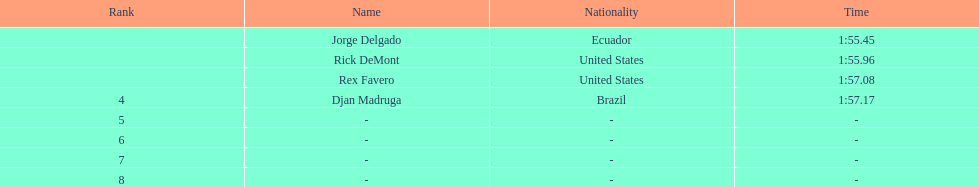What come after rex f. Djan Madruga. 